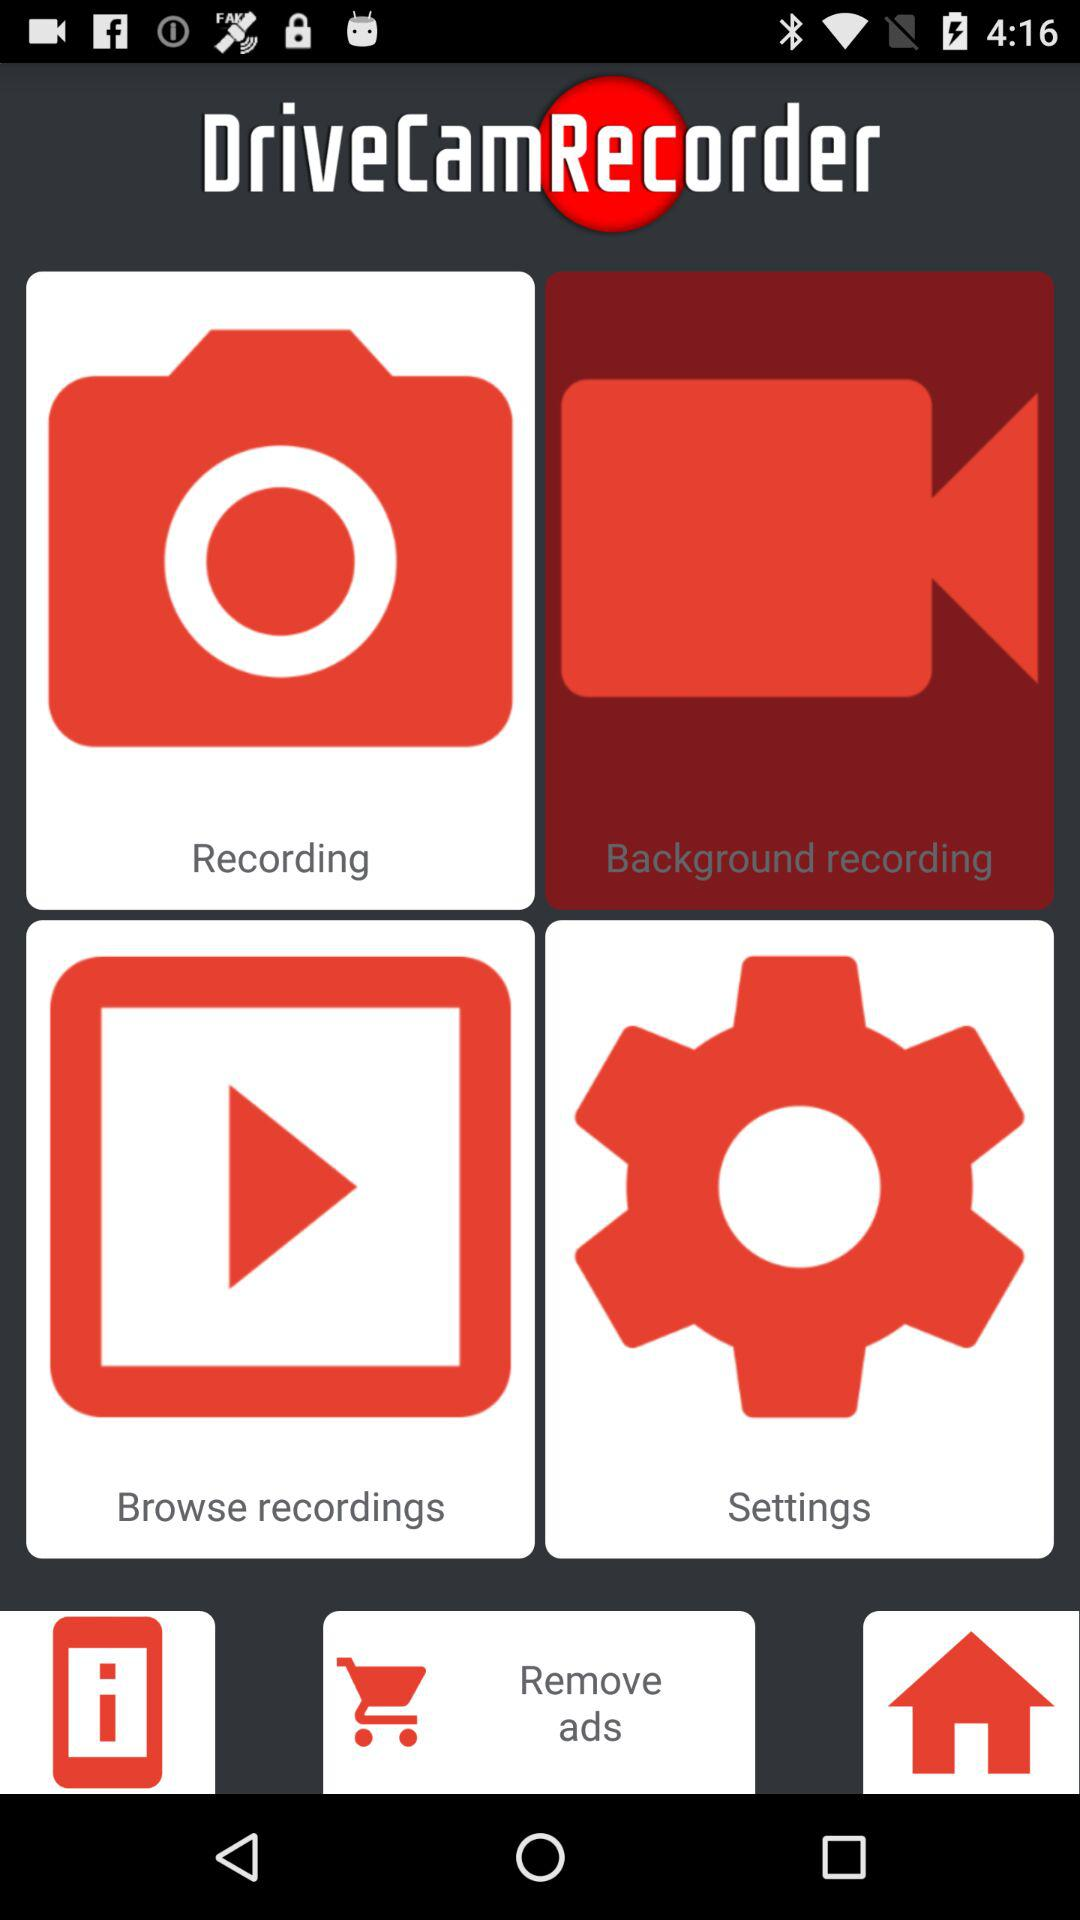What is the name of the application? The name of the application is "DriveCamRecorder". 